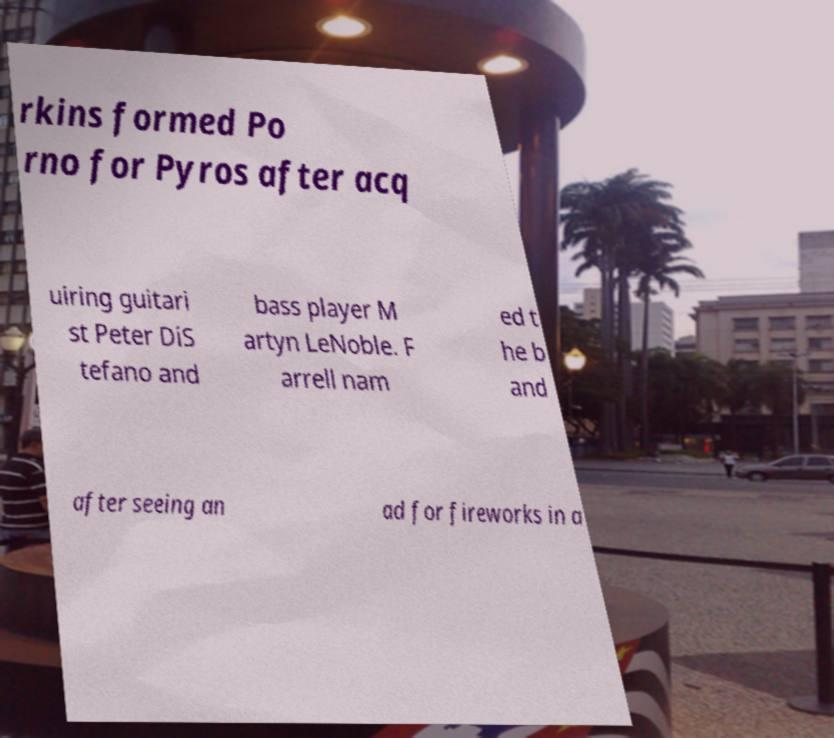Can you read and provide the text displayed in the image?This photo seems to have some interesting text. Can you extract and type it out for me? rkins formed Po rno for Pyros after acq uiring guitari st Peter DiS tefano and bass player M artyn LeNoble. F arrell nam ed t he b and after seeing an ad for fireworks in a 